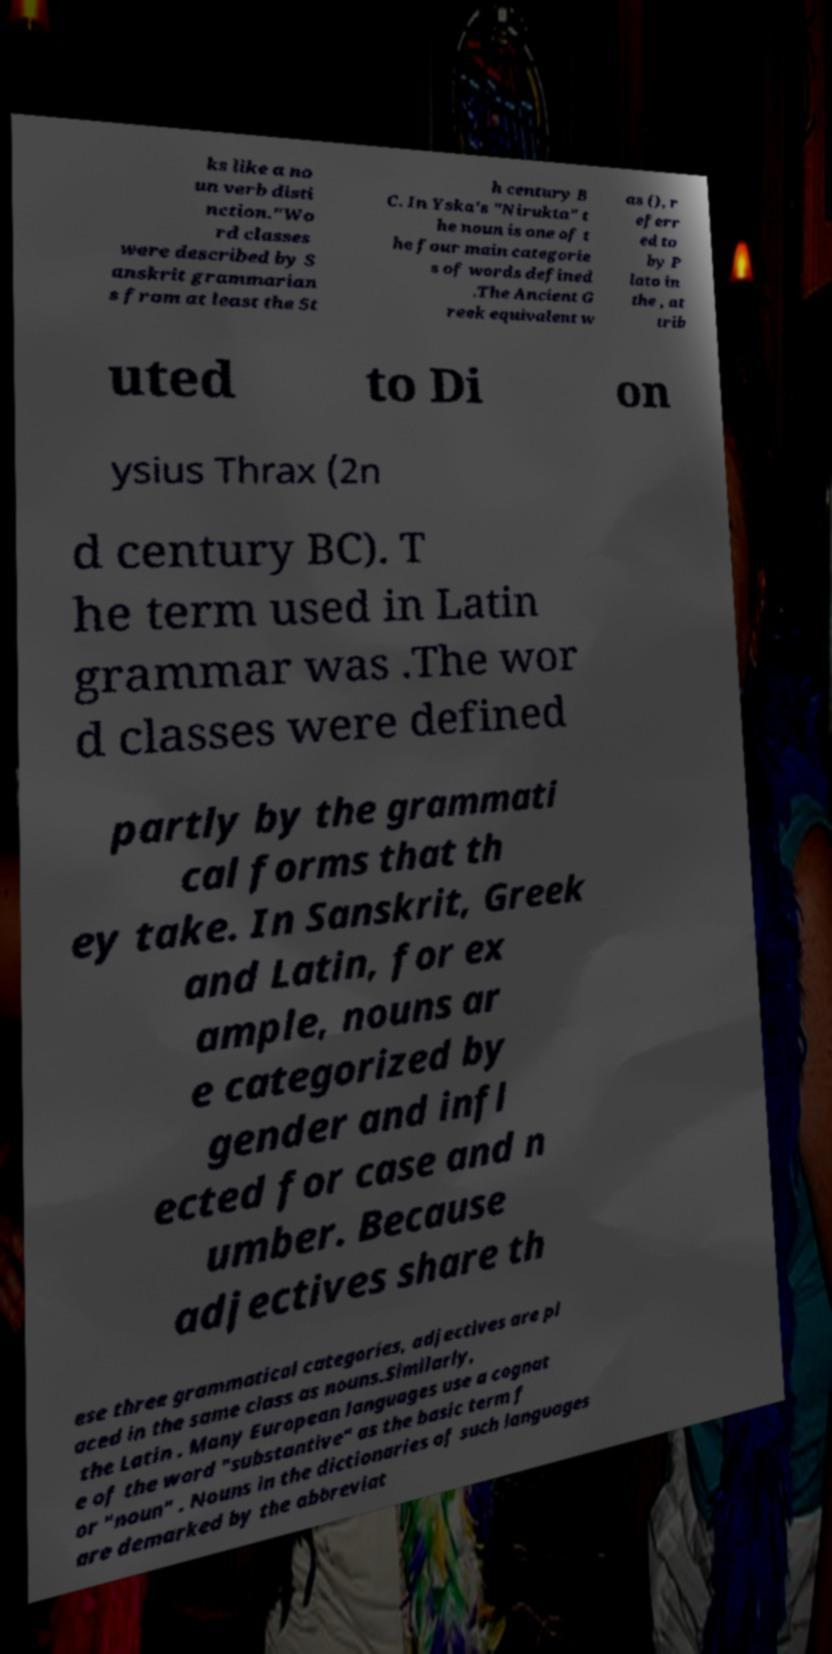There's text embedded in this image that I need extracted. Can you transcribe it verbatim? ks like a no un verb disti nction."Wo rd classes were described by S anskrit grammarian s from at least the 5t h century B C. In Yska's "Nirukta" t he noun is one of t he four main categorie s of words defined .The Ancient G reek equivalent w as (), r eferr ed to by P lato in the , at trib uted to Di on ysius Thrax (2n d century BC). T he term used in Latin grammar was .The wor d classes were defined partly by the grammati cal forms that th ey take. In Sanskrit, Greek and Latin, for ex ample, nouns ar e categorized by gender and infl ected for case and n umber. Because adjectives share th ese three grammatical categories, adjectives are pl aced in the same class as nouns.Similarly, the Latin . Many European languages use a cognat e of the word "substantive" as the basic term f or "noun" . Nouns in the dictionaries of such languages are demarked by the abbreviat 